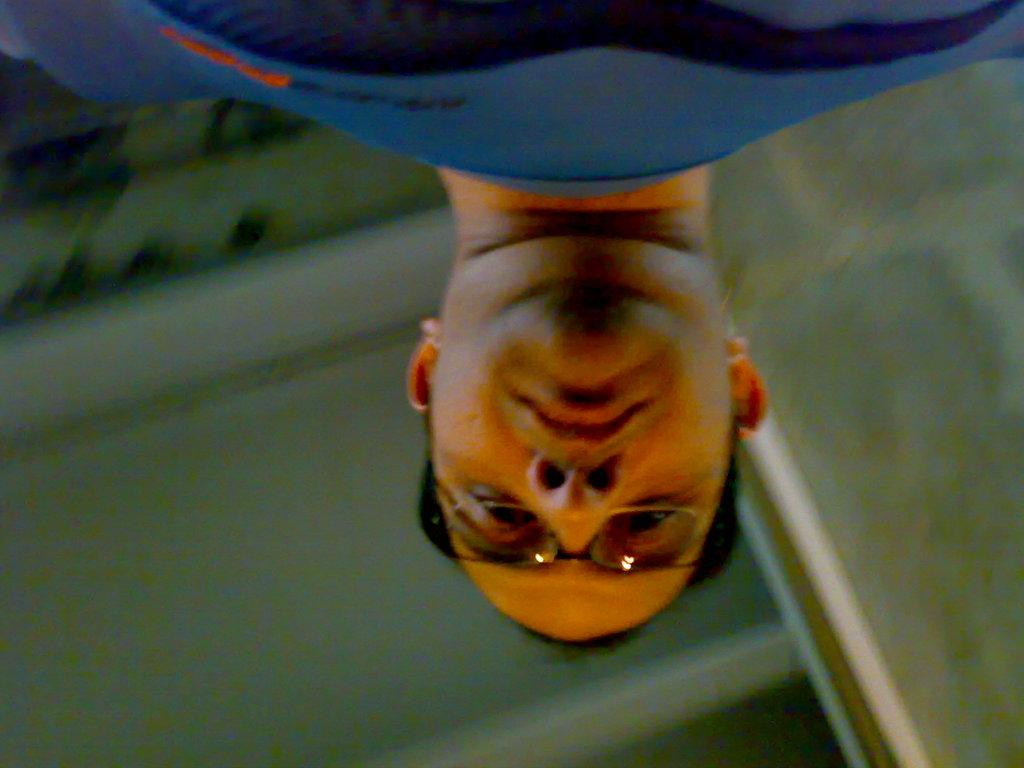Who is the main subject in the image? There is a man in the image. Where is the man positioned in the image? The man is in the front of the image. What can be seen in the background of the image? There is a wall in the background of the image. How many clams are on the man's shoulder in the image? There are no clams present in the image. What type of slip is the man wearing in the image? The image does not show the man wearing any type of slip. 